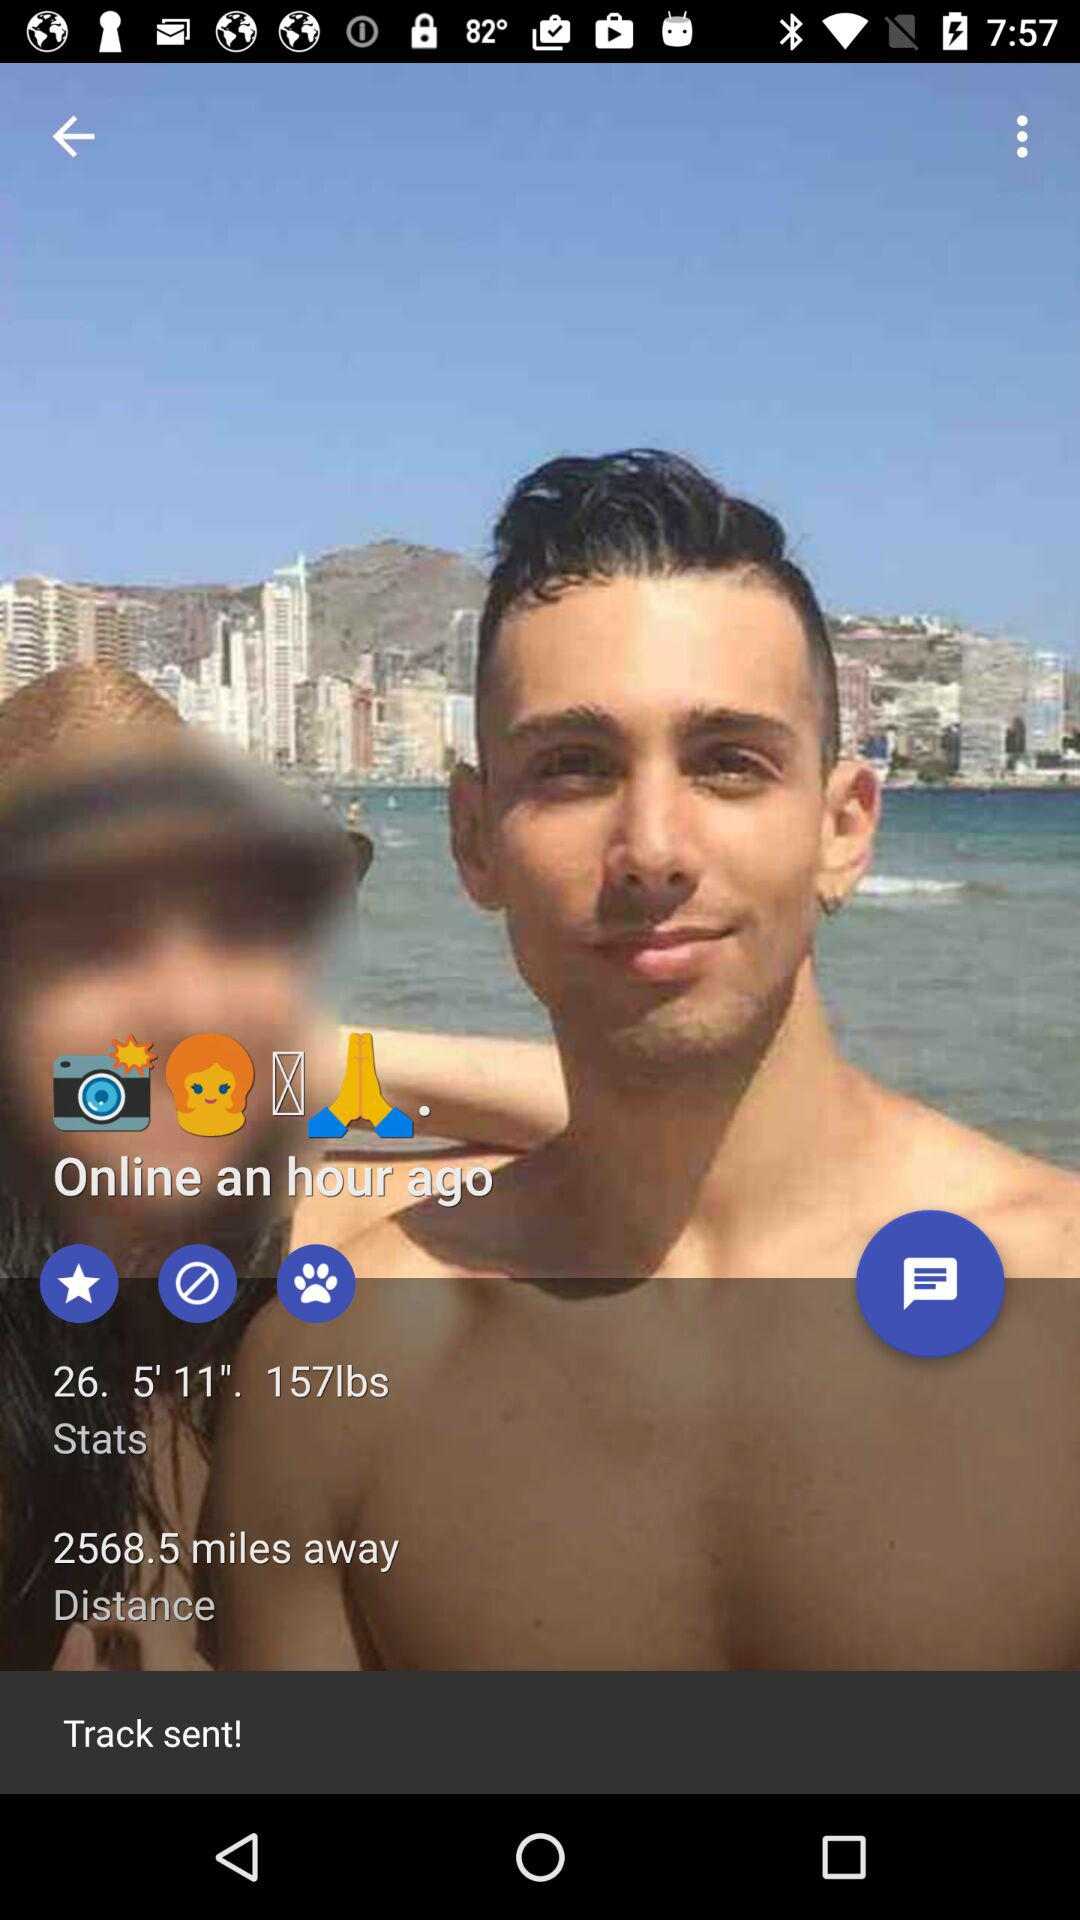What is the height? The height is 5 feet 11 inches. 